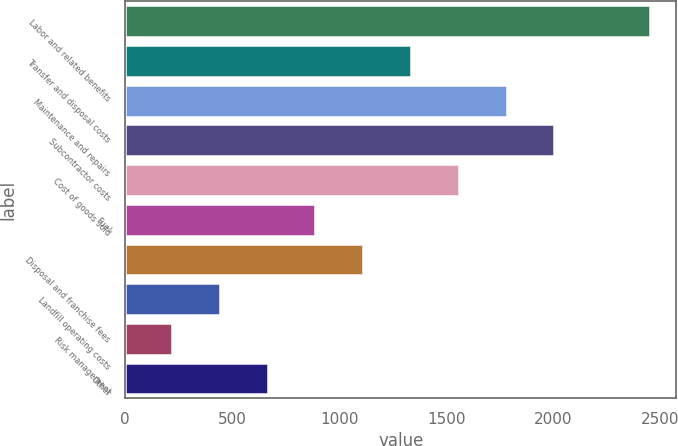Convert chart. <chart><loc_0><loc_0><loc_500><loc_500><bar_chart><fcel>Labor and related benefits<fcel>Transfer and disposal costs<fcel>Maintenance and repairs<fcel>Subcontractor costs<fcel>Cost of goods sold<fcel>Fuel<fcel>Disposal and franchise fees<fcel>Landfill operating costs<fcel>Risk management<fcel>Other<nl><fcel>2452<fcel>1335.5<fcel>1782.1<fcel>2005.4<fcel>1558.8<fcel>888.9<fcel>1112.2<fcel>442.3<fcel>219<fcel>665.6<nl></chart> 